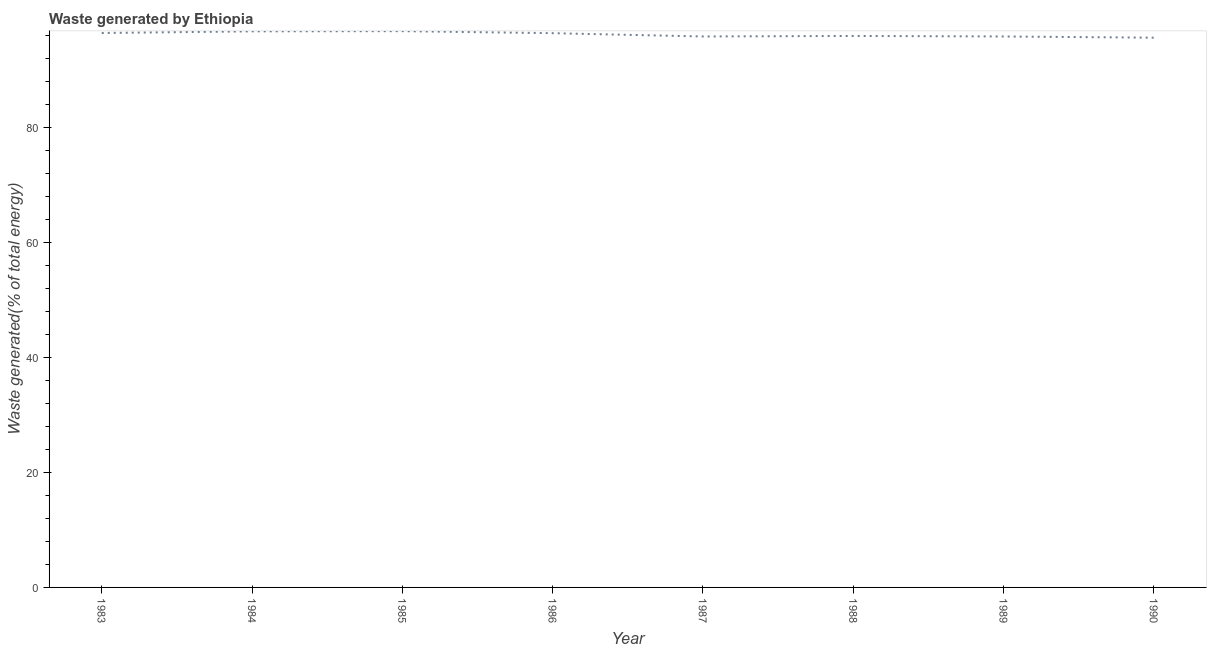What is the amount of waste generated in 1990?
Provide a succinct answer. 95.7. Across all years, what is the maximum amount of waste generated?
Your response must be concise. 96.84. Across all years, what is the minimum amount of waste generated?
Your answer should be compact. 95.7. In which year was the amount of waste generated maximum?
Your response must be concise. 1985. In which year was the amount of waste generated minimum?
Keep it short and to the point. 1990. What is the sum of the amount of waste generated?
Your answer should be very brief. 770.14. What is the difference between the amount of waste generated in 1989 and 1990?
Ensure brevity in your answer.  0.21. What is the average amount of waste generated per year?
Ensure brevity in your answer.  96.27. What is the median amount of waste generated?
Your response must be concise. 96.24. In how many years, is the amount of waste generated greater than 64 %?
Give a very brief answer. 8. Do a majority of the years between 1990 and 1987 (inclusive) have amount of waste generated greater than 40 %?
Your answer should be compact. Yes. What is the ratio of the amount of waste generated in 1984 to that in 1989?
Provide a short and direct response. 1.01. Is the difference between the amount of waste generated in 1986 and 1989 greater than the difference between any two years?
Your response must be concise. No. What is the difference between the highest and the second highest amount of waste generated?
Ensure brevity in your answer.  0.03. Is the sum of the amount of waste generated in 1987 and 1988 greater than the maximum amount of waste generated across all years?
Your answer should be very brief. Yes. What is the difference between the highest and the lowest amount of waste generated?
Ensure brevity in your answer.  1.14. How many years are there in the graph?
Your response must be concise. 8. Are the values on the major ticks of Y-axis written in scientific E-notation?
Offer a very short reply. No. Does the graph contain any zero values?
Give a very brief answer. No. Does the graph contain grids?
Your answer should be compact. No. What is the title of the graph?
Your answer should be very brief. Waste generated by Ethiopia. What is the label or title of the Y-axis?
Offer a very short reply. Waste generated(% of total energy). What is the Waste generated(% of total energy) in 1983?
Ensure brevity in your answer.  96.51. What is the Waste generated(% of total energy) of 1984?
Your answer should be compact. 96.8. What is the Waste generated(% of total energy) of 1985?
Make the answer very short. 96.84. What is the Waste generated(% of total energy) of 1986?
Make the answer very short. 96.48. What is the Waste generated(% of total energy) of 1987?
Provide a succinct answer. 95.91. What is the Waste generated(% of total energy) of 1988?
Your answer should be very brief. 96. What is the Waste generated(% of total energy) in 1989?
Your answer should be very brief. 95.91. What is the Waste generated(% of total energy) of 1990?
Offer a terse response. 95.7. What is the difference between the Waste generated(% of total energy) in 1983 and 1984?
Give a very brief answer. -0.29. What is the difference between the Waste generated(% of total energy) in 1983 and 1985?
Provide a succinct answer. -0.32. What is the difference between the Waste generated(% of total energy) in 1983 and 1986?
Your answer should be compact. 0.03. What is the difference between the Waste generated(% of total energy) in 1983 and 1987?
Provide a succinct answer. 0.6. What is the difference between the Waste generated(% of total energy) in 1983 and 1988?
Provide a short and direct response. 0.51. What is the difference between the Waste generated(% of total energy) in 1983 and 1989?
Keep it short and to the point. 0.6. What is the difference between the Waste generated(% of total energy) in 1983 and 1990?
Your answer should be very brief. 0.81. What is the difference between the Waste generated(% of total energy) in 1984 and 1985?
Provide a short and direct response. -0.03. What is the difference between the Waste generated(% of total energy) in 1984 and 1986?
Offer a terse response. 0.32. What is the difference between the Waste generated(% of total energy) in 1984 and 1987?
Keep it short and to the point. 0.89. What is the difference between the Waste generated(% of total energy) in 1984 and 1988?
Give a very brief answer. 0.8. What is the difference between the Waste generated(% of total energy) in 1984 and 1989?
Your answer should be compact. 0.89. What is the difference between the Waste generated(% of total energy) in 1984 and 1990?
Offer a very short reply. 1.1. What is the difference between the Waste generated(% of total energy) in 1985 and 1986?
Ensure brevity in your answer.  0.35. What is the difference between the Waste generated(% of total energy) in 1985 and 1987?
Offer a very short reply. 0.93. What is the difference between the Waste generated(% of total energy) in 1985 and 1988?
Your response must be concise. 0.84. What is the difference between the Waste generated(% of total energy) in 1985 and 1989?
Give a very brief answer. 0.93. What is the difference between the Waste generated(% of total energy) in 1985 and 1990?
Your response must be concise. 1.14. What is the difference between the Waste generated(% of total energy) in 1986 and 1987?
Your answer should be compact. 0.57. What is the difference between the Waste generated(% of total energy) in 1986 and 1988?
Your answer should be very brief. 0.48. What is the difference between the Waste generated(% of total energy) in 1986 and 1989?
Ensure brevity in your answer.  0.57. What is the difference between the Waste generated(% of total energy) in 1986 and 1990?
Make the answer very short. 0.78. What is the difference between the Waste generated(% of total energy) in 1987 and 1988?
Keep it short and to the point. -0.09. What is the difference between the Waste generated(% of total energy) in 1987 and 1989?
Offer a very short reply. 0. What is the difference between the Waste generated(% of total energy) in 1987 and 1990?
Offer a very short reply. 0.21. What is the difference between the Waste generated(% of total energy) in 1988 and 1989?
Your response must be concise. 0.09. What is the difference between the Waste generated(% of total energy) in 1988 and 1990?
Provide a succinct answer. 0.3. What is the difference between the Waste generated(% of total energy) in 1989 and 1990?
Your response must be concise. 0.21. What is the ratio of the Waste generated(% of total energy) in 1983 to that in 1984?
Your answer should be very brief. 1. What is the ratio of the Waste generated(% of total energy) in 1983 to that in 1986?
Your answer should be compact. 1. What is the ratio of the Waste generated(% of total energy) in 1983 to that in 1987?
Provide a short and direct response. 1.01. What is the ratio of the Waste generated(% of total energy) in 1983 to that in 1988?
Keep it short and to the point. 1. What is the ratio of the Waste generated(% of total energy) in 1984 to that in 1985?
Your response must be concise. 1. What is the ratio of the Waste generated(% of total energy) in 1984 to that in 1986?
Give a very brief answer. 1. What is the ratio of the Waste generated(% of total energy) in 1984 to that in 1989?
Offer a terse response. 1.01. What is the ratio of the Waste generated(% of total energy) in 1985 to that in 1986?
Your answer should be very brief. 1. What is the ratio of the Waste generated(% of total energy) in 1985 to that in 1987?
Offer a terse response. 1.01. What is the ratio of the Waste generated(% of total energy) in 1985 to that in 1988?
Provide a short and direct response. 1.01. What is the ratio of the Waste generated(% of total energy) in 1985 to that in 1989?
Your answer should be very brief. 1.01. What is the ratio of the Waste generated(% of total energy) in 1985 to that in 1990?
Provide a short and direct response. 1.01. What is the ratio of the Waste generated(% of total energy) in 1986 to that in 1989?
Keep it short and to the point. 1.01. What is the ratio of the Waste generated(% of total energy) in 1986 to that in 1990?
Offer a very short reply. 1.01. What is the ratio of the Waste generated(% of total energy) in 1987 to that in 1989?
Provide a short and direct response. 1. What is the ratio of the Waste generated(% of total energy) in 1987 to that in 1990?
Give a very brief answer. 1. 